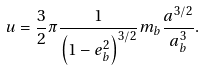Convert formula to latex. <formula><loc_0><loc_0><loc_500><loc_500>u = \frac { 3 } { 2 } \pi \frac { 1 } { \left ( 1 - e _ { b } ^ { 2 } \right ) ^ { 3 / 2 } } m _ { b } \frac { a ^ { 3 / 2 } } { a _ { b } ^ { 3 } } .</formula> 